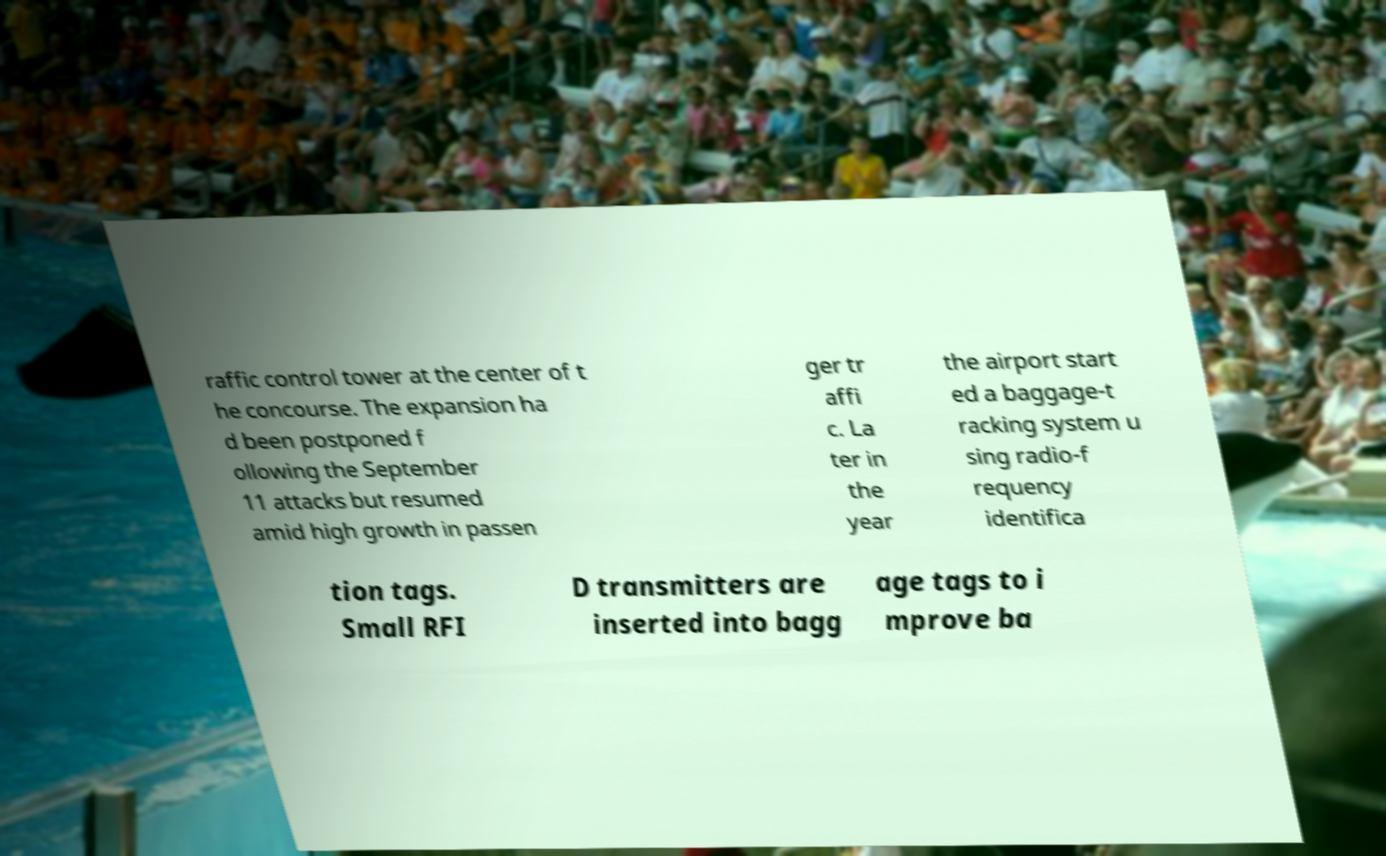Can you accurately transcribe the text from the provided image for me? raffic control tower at the center of t he concourse. The expansion ha d been postponed f ollowing the September 11 attacks but resumed amid high growth in passen ger tr affi c. La ter in the year the airport start ed a baggage-t racking system u sing radio-f requency identifica tion tags. Small RFI D transmitters are inserted into bagg age tags to i mprove ba 